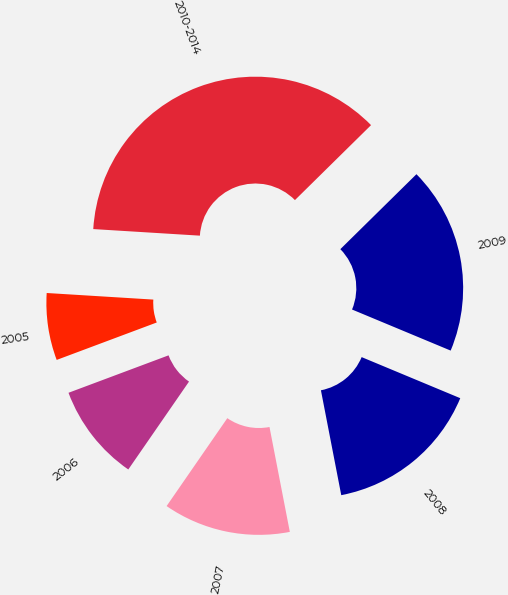Convert chart. <chart><loc_0><loc_0><loc_500><loc_500><pie_chart><fcel>2005<fcel>2006<fcel>2007<fcel>2008<fcel>2009<fcel>2010-2014<nl><fcel>6.68%<fcel>9.68%<fcel>12.67%<fcel>15.67%<fcel>18.66%<fcel>36.64%<nl></chart> 